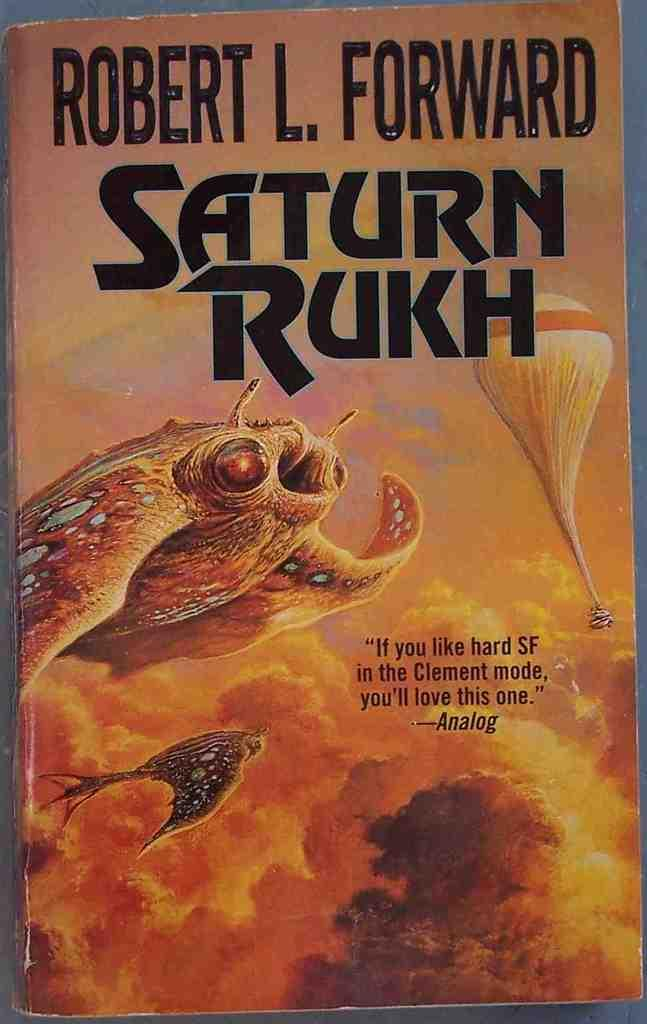<image>
Provide a brief description of the given image. the title of the book is Saturn Rukh 